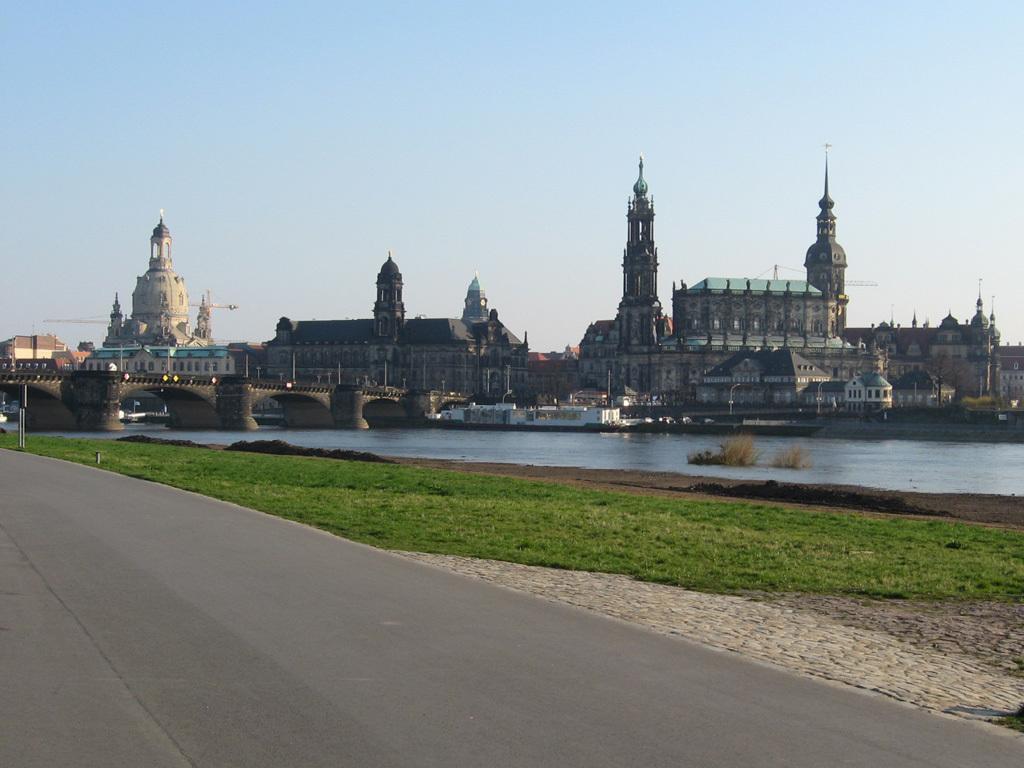Please provide a concise description of this image. This is the picture of a city. In this image there are buildings and trees and there are poles. On the left side of the image there is a bridge and there is a boat on the water. At the top there is sky. At the bottom there is water and there is grass and there is a road. 